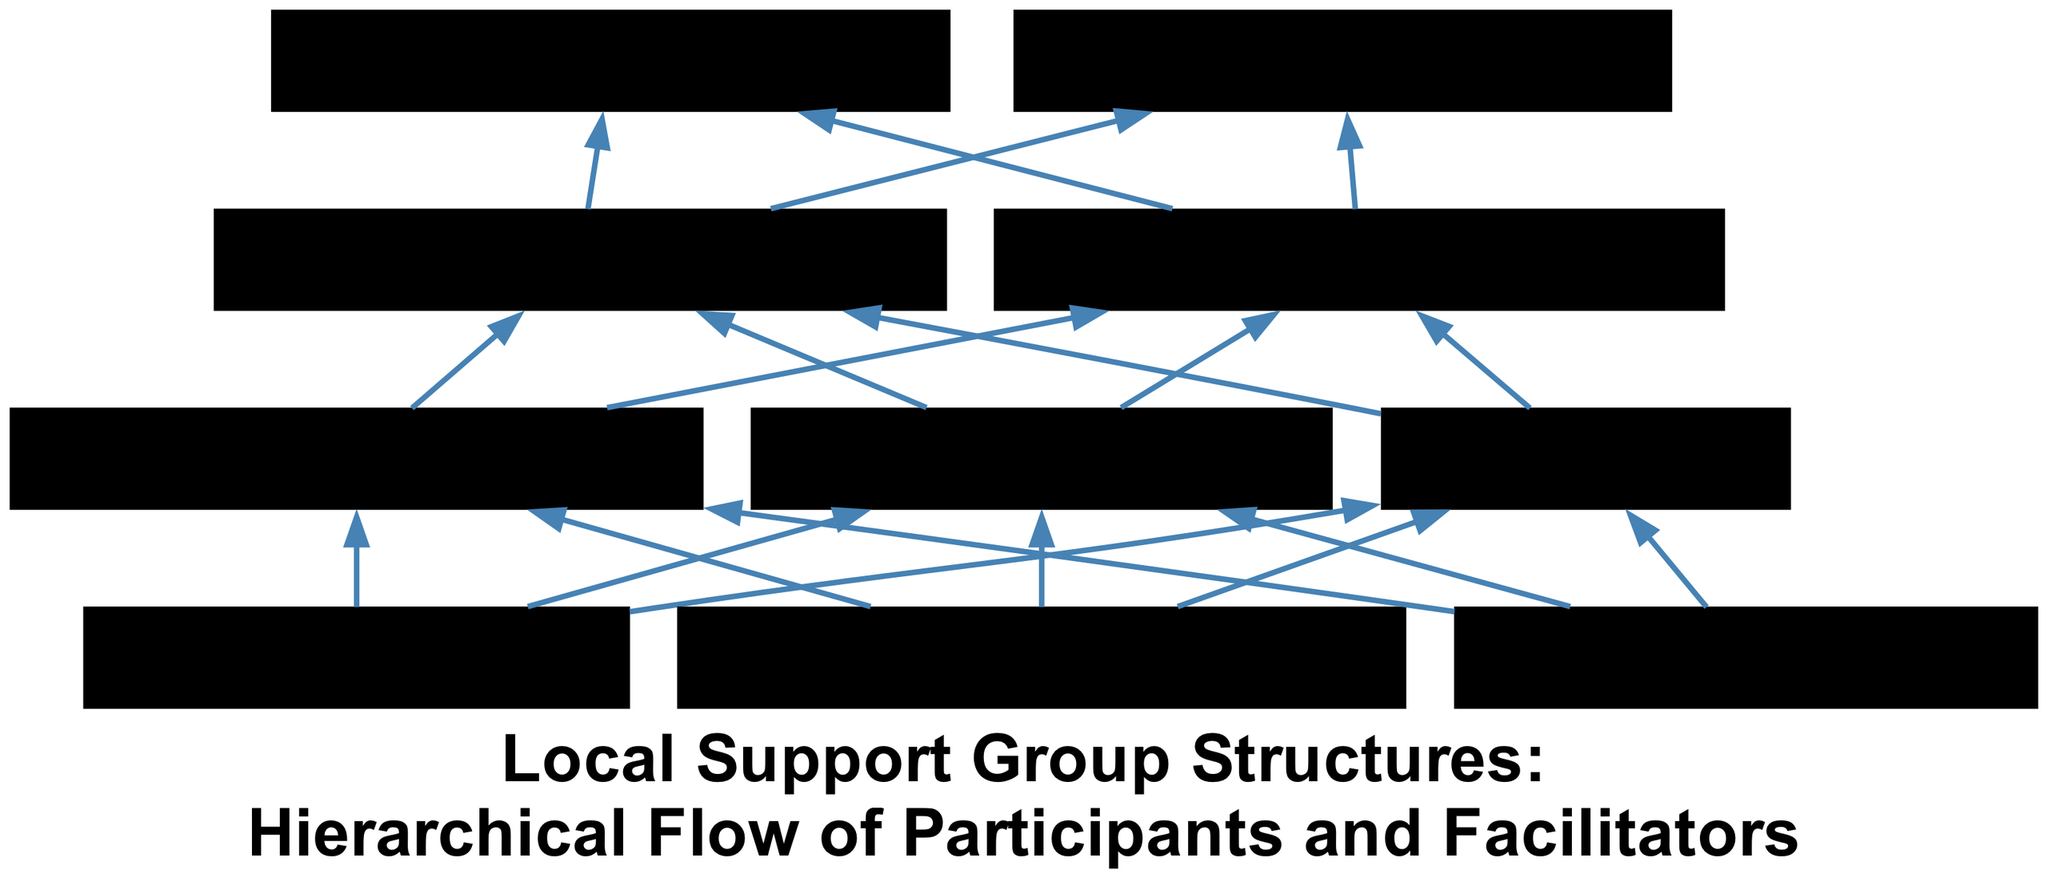What is the top-level group in the hierarchy? The top-most level in the hierarchy represents the "Administrative Oversight," which is concerned with the overall management and governance of the support group structures.
Answer: Administrative Oversight How many entities are in the "Participants" level? Checking the "Participants" level, there are three specific entities listed: Peer Support Participants, Mental Health Awareness Advocates, and Individuals Seeking Support.
Answer: 3 Who are the "Support Group Leaders"? The "Support Group Leaders" are represented by two specific entities: Group Moderators from Local NGOs and Experienced Support Group Leaders.
Answer: Group Moderators from Local NGOs, Experienced Support Group Leaders Which group connects directly to the "Facilitators" level? The connection flows upward from "Participants" to "Facilitators." This indicates that "Participants" provide the foundational support that is facilitated by the next hierarchical level.
Answer: Participants How many edges are there connecting the "Facilitators" to "Support Group Leaders"? The "Facilitators" level connects to the "Support Group Leaders" level through edges leading from each facilitator to each group leader entity, resulting in a total of six distinct connections (3 facilitators * 2 leaders).
Answer: 6 Which entity is at the bottom of the hierarchy? At the bottom of the hierarchy, the foundation consists of "Participants," forming the initial group that supports mental health initiatives at the grassroots level.
Answer: Participants What is the main function of the "Mental Health Coalition of Bataan"? The primary function of the "Mental Health Coalition of Bataan" is to provide administrative oversight and support for all the entities in the flow chart, ensuring coordination and effective community mental health strategies.
Answer: Administrative oversight How does the flow chart illustrate the relationship between "Facilitators" and "Participants"? The flow chart shows that "Facilitators" function above "Participants," indicating that they support and guide the lower-level entities, enhancing the effectiveness of mental health support being provided.
Answer: Supports What level has the fewest entities shown in the diagram? Among all the levels illustrated, the "Support Group Leaders" level has the least number of entities with only two entities present compared to other levels.
Answer: 2 